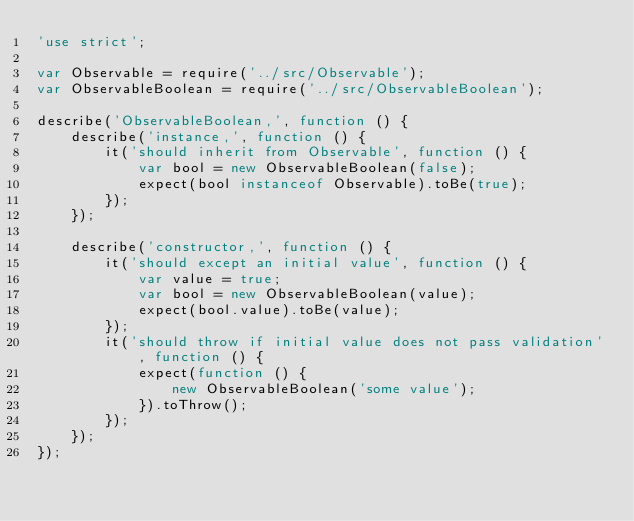Convert code to text. <code><loc_0><loc_0><loc_500><loc_500><_JavaScript_>'use strict';

var Observable = require('../src/Observable');
var ObservableBoolean = require('../src/ObservableBoolean');

describe('ObservableBoolean,', function () {
    describe('instance,', function () {
        it('should inherit from Observable', function () {
            var bool = new ObservableBoolean(false);
            expect(bool instanceof Observable).toBe(true);
        });
    });

    describe('constructor,', function () {
        it('should except an initial value', function () {
            var value = true;
            var bool = new ObservableBoolean(value);
            expect(bool.value).toBe(value);
        });
        it('should throw if initial value does not pass validation', function () {
            expect(function () {
                new ObservableBoolean('some value');
            }).toThrow();
        });
    });
});</code> 